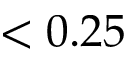<formula> <loc_0><loc_0><loc_500><loc_500>< 0 . 2 5</formula> 